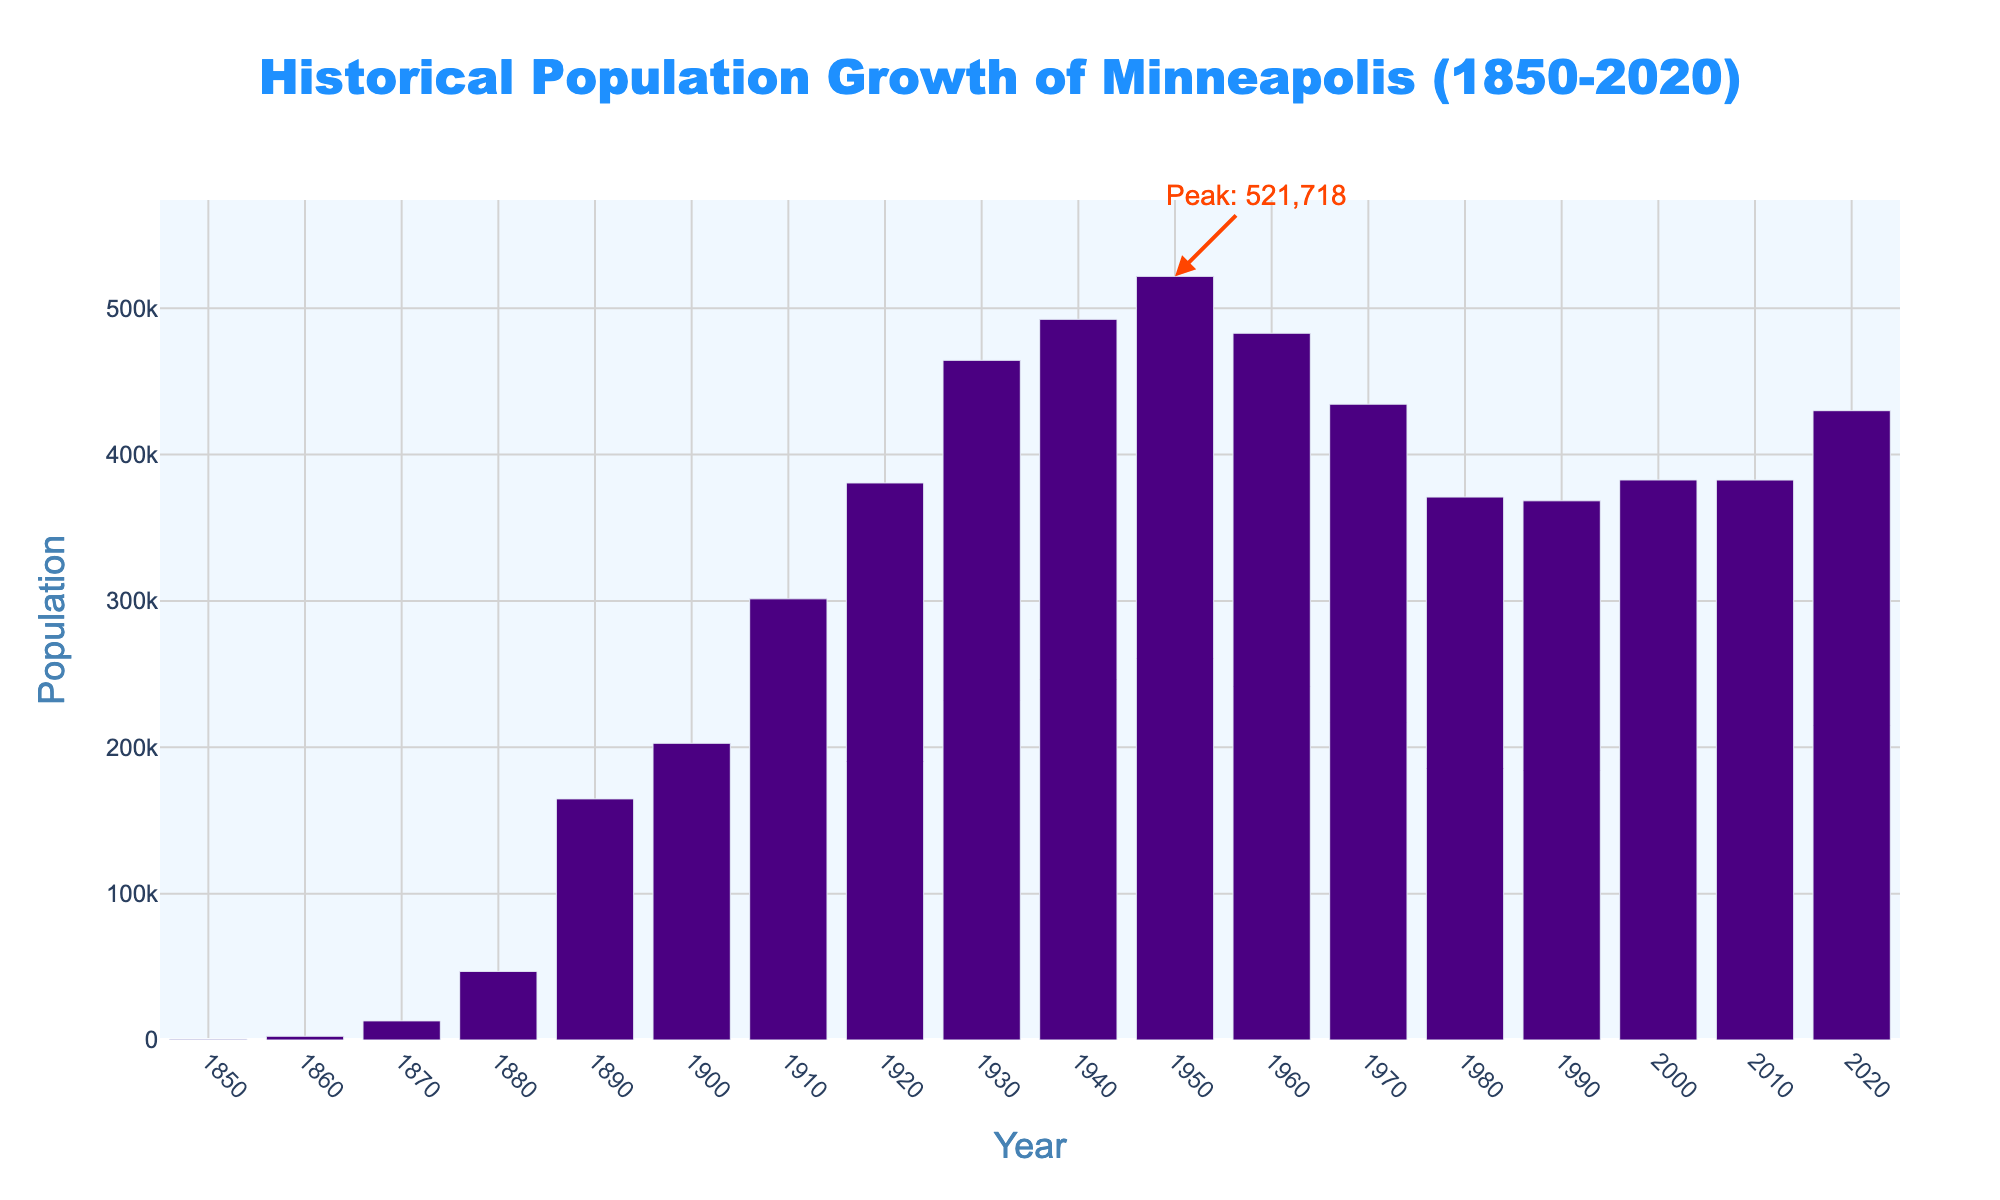Which decade had the highest population? The figure has a highlighted annotation indicating the peak population, which occurs around the year 1950.
Answer: 1950s What was the population in 1900? Locate the bar corresponding to the year 1900 and read off the population value.
Answer: 202,718 How much did the population increase from 1900 to 1910? Subtract the population in 1900 from the population in 1910. (301,408 - 202,718)
Answer: 98,690 What is the difference in population between the peak in 1950 and 2020? Subtract the 2020 population from the 1950 population. (521,718 - 429,954)
Answer: 91,764 Which decade saw the largest population decline? Identify the bars and calculate the difference for each decade, then find the maximum decline. The biggest decline is from 1950 to 1960. (521,718 - 482,872)
Answer: 1950s to 1960s How did the population change between 1860 and 1880? Locate the bars for 1860 and 1880, and perform the subtraction. (46,887 - 2,564)
Answer: Increased by 44,323 What is the average population between 1920 and 1940? Sum the populations of 1920, 1930, and 1940, and then divide by 3. ((380,582 + 464,356 + 492,370) / 3)
Answer: 445,769 Which decade experienced the smallest population growth? Calculate the differences for each decade and identify the smallest one. The smallest growth is from 1990 to 2000. (382,618 - 368,383)
Answer: 1990s to 2000s What is the median population value for the data shown? Sort the population values and find the middle one. The middle value (when the data is ordered) corresponds to the year 1930, with a population of 464,356.
Answer: 464,356 How many decades saw a decline in population? Count the number of bars where the population decreased compared to the previous decade.
Answer: 4 